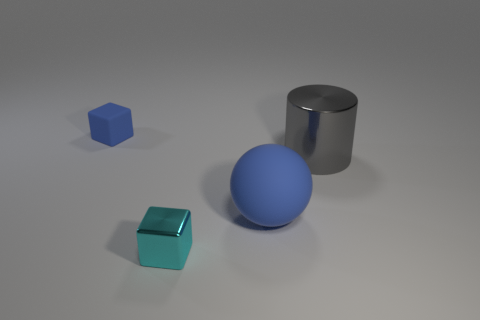Are there any brown metallic spheres of the same size as the gray metallic object?
Make the answer very short. No. What size is the rubber thing to the left of the tiny cyan thing?
Offer a terse response. Small. What is the size of the blue matte cube?
Keep it short and to the point. Small. What number of blocks are either big blue matte things or big objects?
Make the answer very short. 0. There is a cube that is the same material as the large gray cylinder; what is its size?
Give a very brief answer. Small. What number of rubber spheres are the same color as the rubber block?
Ensure brevity in your answer.  1. There is a blue block; are there any gray cylinders to the left of it?
Give a very brief answer. No. There is a gray object; is it the same shape as the blue thing to the left of the matte sphere?
Give a very brief answer. No. How many things are either large things left of the big gray cylinder or small things?
Ensure brevity in your answer.  3. Is there anything else that has the same material as the large gray object?
Your response must be concise. Yes. 